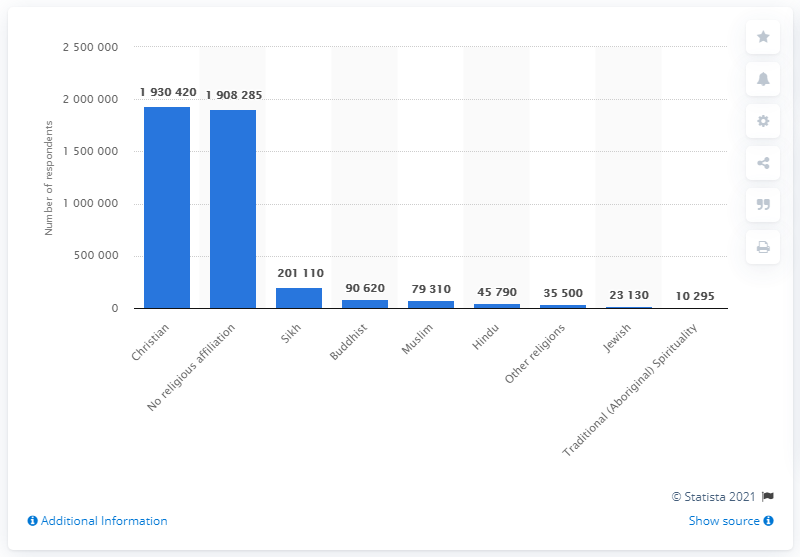Identify some key points in this picture. Approximately 2 million Canadian citizens and permanent/non-permanent residents of British Columbia in 2011 identified as Christian, according to a reported statistic. 